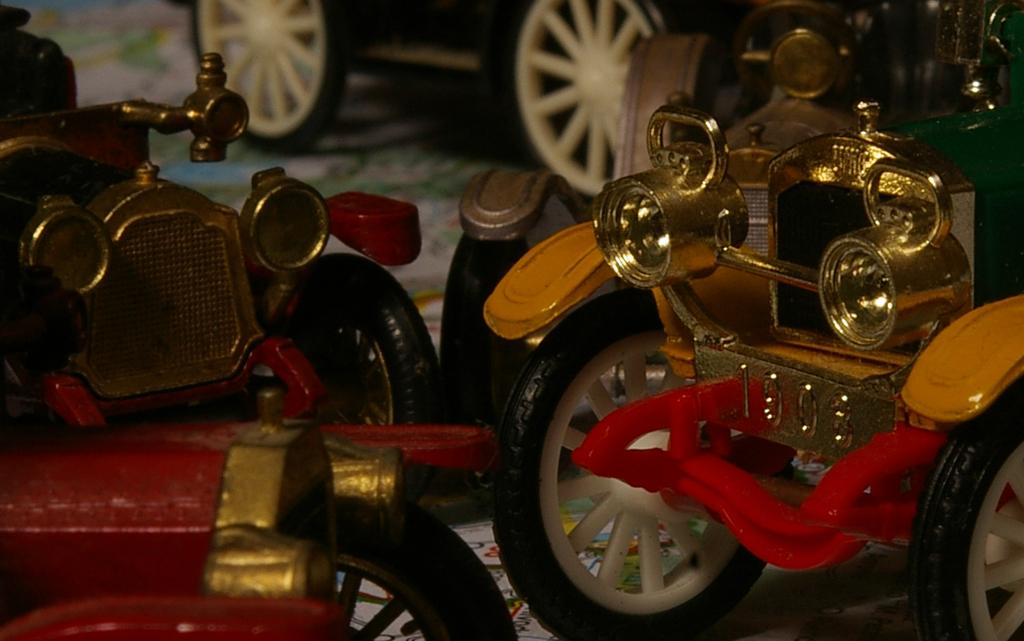What type of toys are present in the image? There are toy cars in the image. Can you describe the appearance of the toy cars? The toy cars are small-scale replicas of real cars. Are the toy cars the only objects present in the image? The facts provided only mention toy cars, so it can be assumed that they are the main focus of the image. How many tickets are attached to each toy car in the image? There are no tickets present in the image; it only features toy cars. Can you describe the ornamental features of the toy cars in the image? The facts provided do not mention any ornamental features of the toy cars, so it cannot be determined from the image. 